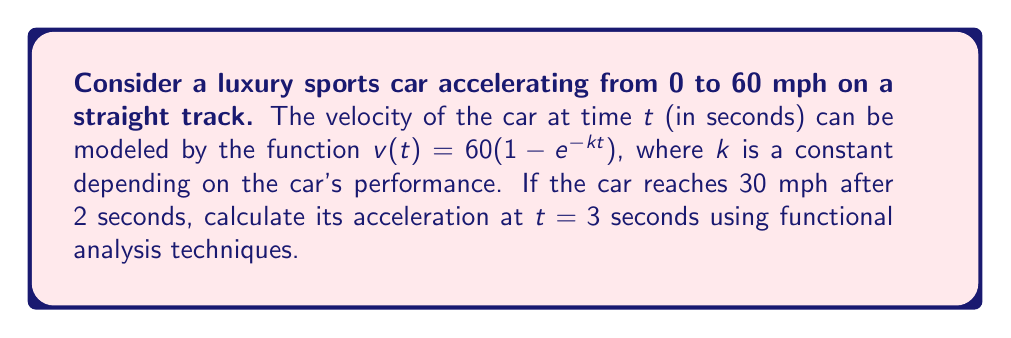Provide a solution to this math problem. Let's approach this problem step by step using functional analysis:

1) First, we need to find the value of $k$. We know that at $t = 2$ seconds, $v(2) = 30$ mph:

   $30 = 60(1 - e^{-2k})$
   $\frac{1}{2} = 1 - e^{-2k}$
   $e^{-2k} = \frac{1}{2}$
   $-2k = \ln(\frac{1}{2}) = -\ln(2)$
   $k = \frac{\ln(2)}{2}$

2) Now that we have $k$, we can define our velocity function in the space of continuous functions $C[0,\infty)$:

   $v(t) = 60(1 - e^{-\frac{\ln(2)}{2}t})$

3) To find acceleration, we need to differentiate $v(t)$. In functional analysis, we can view this as applying a linear operator $D: C^1[0,\infty) \to C[0,\infty)$ defined by $Df = f'$:

   $a(t) = Dv(t) = v'(t) = 60 \cdot \frac{\ln(2)}{2} \cdot e^{-\frac{\ln(2)}{2}t}$

4) Now, we need to evaluate this function at $t = 3$:

   $a(3) = 60 \cdot \frac{\ln(2)}{2} \cdot e^{-\frac{\ln(2)}{2} \cdot 3}$

5) Let's calculate this value:

   $a(3) = 60 \cdot \frac{\ln(2)}{2} \cdot e^{-\frac{3\ln(2)}{2}}$
         $= 30\ln(2) \cdot (\frac{1}{2})^{\frac{3}{2}}$
         $= 30\ln(2) \cdot \frac{1}{2\sqrt{2}}$
         $= \frac{15\ln(2)}{\sqrt{2}}$
         $\approx 7.32$ mph/s

6) Convert to m/s^2:

   $7.32$ mph/s $\cdot \frac{1609.34 \text{ m}}{3600 \text{ s}} \approx 3.27$ m/s^2
Answer: The acceleration of the luxury sports car at $t = 3$ seconds is approximately $3.27$ m/s^2. 